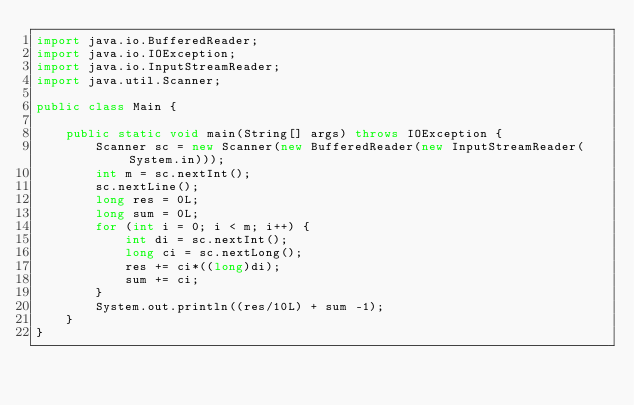<code> <loc_0><loc_0><loc_500><loc_500><_Java_>import java.io.BufferedReader;
import java.io.IOException;
import java.io.InputStreamReader;
import java.util.Scanner;

public class Main {

    public static void main(String[] args) throws IOException {
        Scanner sc = new Scanner(new BufferedReader(new InputStreamReader(System.in)));
        int m = sc.nextInt();
        sc.nextLine();
        long res = 0L;
        long sum = 0L;
        for (int i = 0; i < m; i++) {
            int di = sc.nextInt();
            long ci = sc.nextLong();
            res += ci*((long)di);
            sum += ci;
        }
        System.out.println((res/10L) + sum -1);
    }
}
</code> 